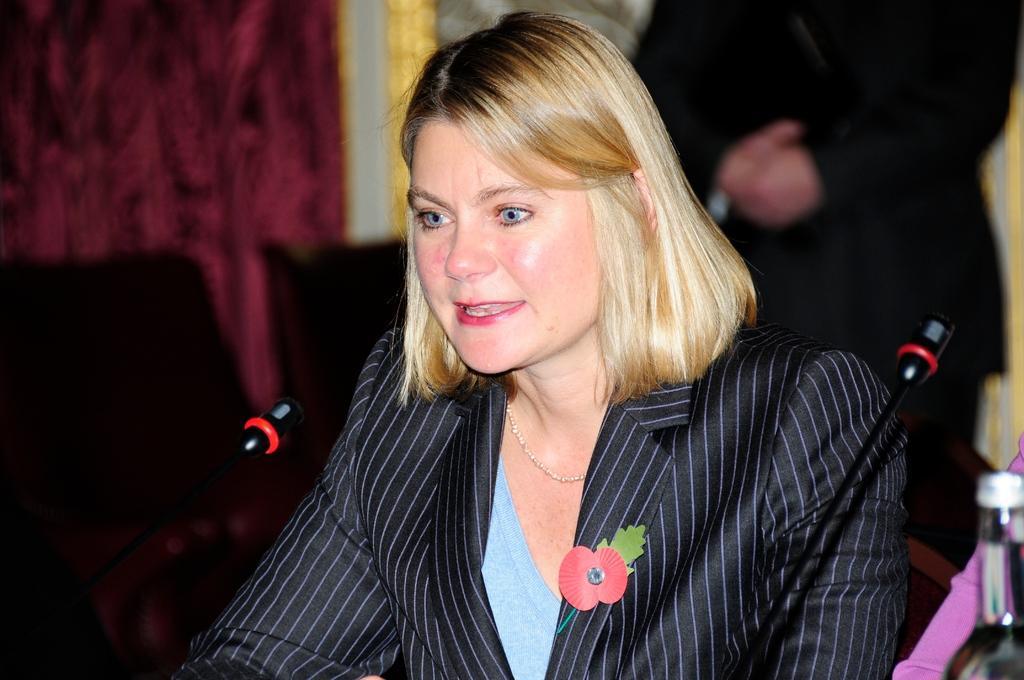How would you summarize this image in a sentence or two? In this image I can see a woman in the front and I can see she is wearing black colour blazer. I can also see few mics and a bottle in the front of her and in the background I can see one person is standing. I can also see a red colour thing on the left side and I can see this image is little bit blurry in the background. 